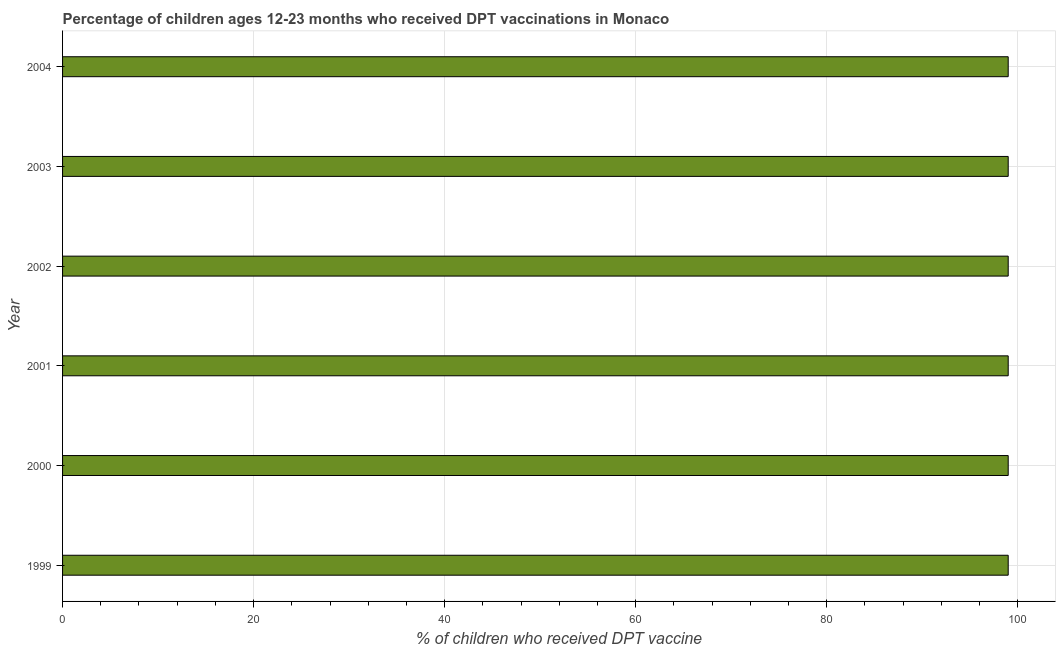What is the title of the graph?
Your answer should be very brief. Percentage of children ages 12-23 months who received DPT vaccinations in Monaco. What is the label or title of the X-axis?
Offer a very short reply. % of children who received DPT vaccine. What is the label or title of the Y-axis?
Provide a succinct answer. Year. What is the percentage of children who received dpt vaccine in 2004?
Offer a terse response. 99. Across all years, what is the minimum percentage of children who received dpt vaccine?
Ensure brevity in your answer.  99. In which year was the percentage of children who received dpt vaccine maximum?
Keep it short and to the point. 1999. In which year was the percentage of children who received dpt vaccine minimum?
Provide a succinct answer. 1999. What is the sum of the percentage of children who received dpt vaccine?
Keep it short and to the point. 594. What is the difference between the percentage of children who received dpt vaccine in 1999 and 2001?
Provide a succinct answer. 0. In how many years, is the percentage of children who received dpt vaccine greater than 20 %?
Give a very brief answer. 6. Do a majority of the years between 1999 and 2000 (inclusive) have percentage of children who received dpt vaccine greater than 20 %?
Make the answer very short. Yes. Is the percentage of children who received dpt vaccine in 2002 less than that in 2003?
Offer a terse response. No. What is the difference between the highest and the lowest percentage of children who received dpt vaccine?
Your answer should be very brief. 0. How many bars are there?
Keep it short and to the point. 6. Are all the bars in the graph horizontal?
Provide a short and direct response. Yes. What is the difference between the % of children who received DPT vaccine in 1999 and 2000?
Make the answer very short. 0. What is the difference between the % of children who received DPT vaccine in 1999 and 2001?
Provide a short and direct response. 0. What is the difference between the % of children who received DPT vaccine in 1999 and 2004?
Ensure brevity in your answer.  0. What is the difference between the % of children who received DPT vaccine in 2000 and 2002?
Your answer should be compact. 0. What is the difference between the % of children who received DPT vaccine in 2000 and 2003?
Your answer should be compact. 0. What is the difference between the % of children who received DPT vaccine in 2000 and 2004?
Make the answer very short. 0. What is the difference between the % of children who received DPT vaccine in 2001 and 2003?
Your answer should be very brief. 0. What is the difference between the % of children who received DPT vaccine in 2001 and 2004?
Keep it short and to the point. 0. What is the difference between the % of children who received DPT vaccine in 2003 and 2004?
Keep it short and to the point. 0. What is the ratio of the % of children who received DPT vaccine in 1999 to that in 2001?
Provide a short and direct response. 1. What is the ratio of the % of children who received DPT vaccine in 2000 to that in 2001?
Provide a short and direct response. 1. What is the ratio of the % of children who received DPT vaccine in 2000 to that in 2004?
Your answer should be very brief. 1. What is the ratio of the % of children who received DPT vaccine in 2001 to that in 2002?
Your answer should be compact. 1. What is the ratio of the % of children who received DPT vaccine in 2002 to that in 2004?
Provide a succinct answer. 1. 